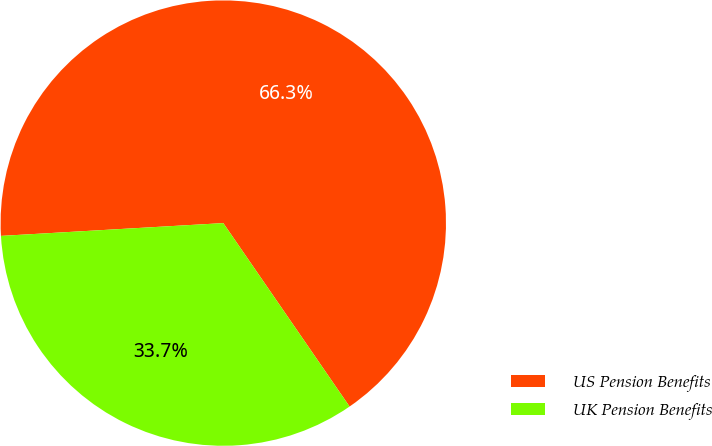Convert chart to OTSL. <chart><loc_0><loc_0><loc_500><loc_500><pie_chart><fcel>US Pension Benefits<fcel>UK Pension Benefits<nl><fcel>66.32%<fcel>33.68%<nl></chart> 